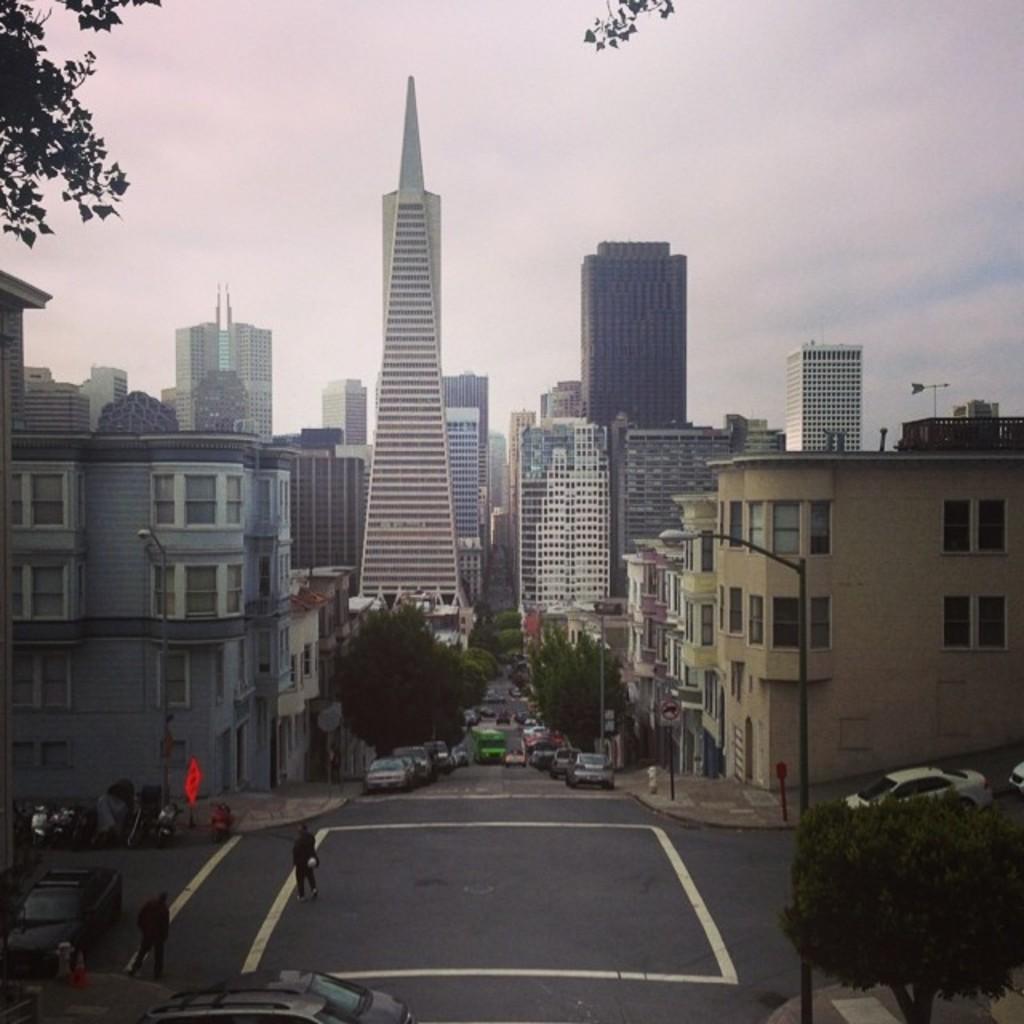Can you describe this image briefly? In this picture I can see vehicles on the road, there are buildings, there are poles, lights, there are trees, and in the background there is the sky. 